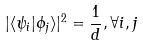Convert formula to latex. <formula><loc_0><loc_0><loc_500><loc_500>| \langle \psi _ { i } | \phi _ { j } \rangle | ^ { 2 } = \frac { 1 } { d } , \forall i , j</formula> 